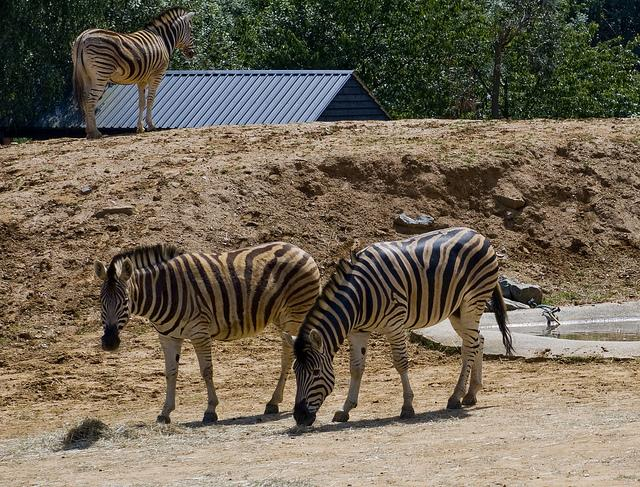How many zebras are walking around on top of the dirt in the courtyard? Please explain your reasoning. three. Several black and white striped animals are in an enclosure. 